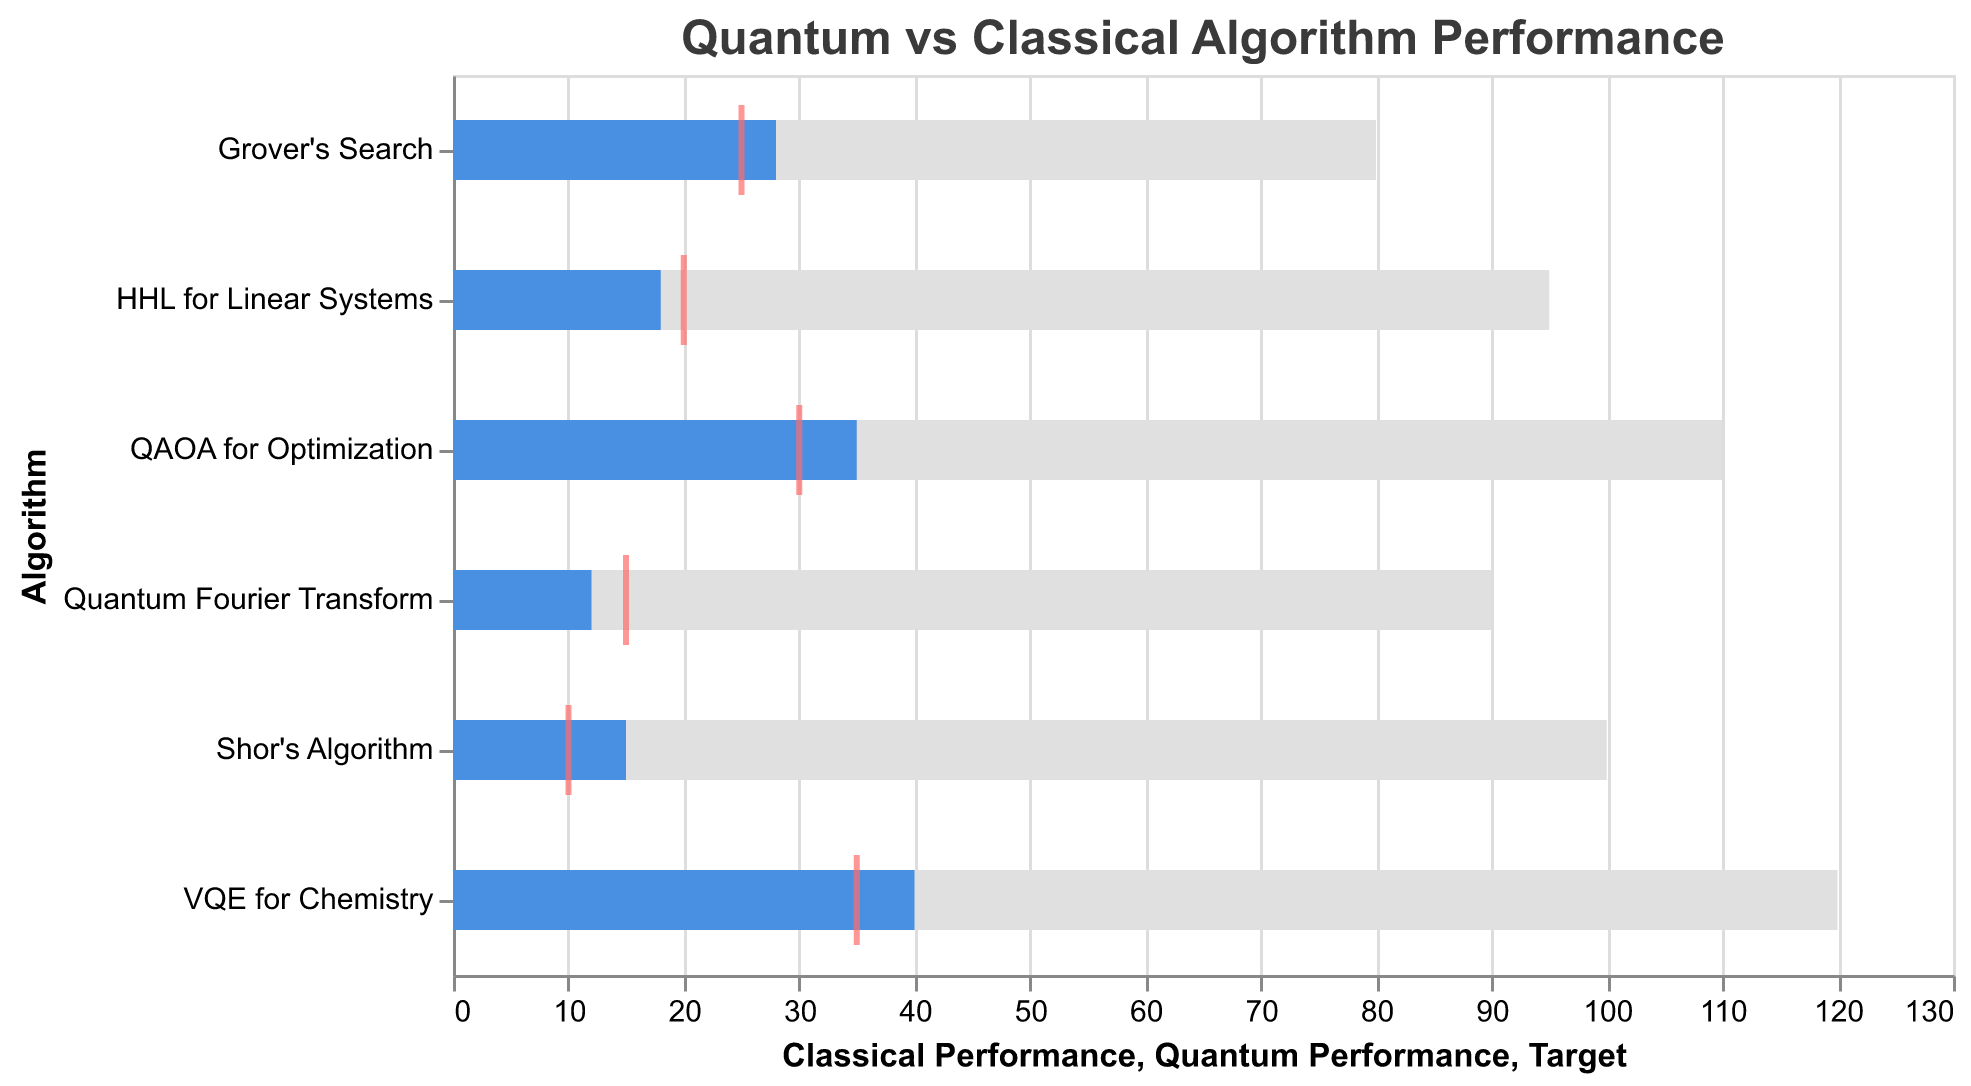What's the title of the figure? The title of the figure is written at the top and usually describes the main subject of the plot. Here, it reads "Quantum vs Classical Algorithm Performance".
Answer: Quantum vs Classical Algorithm Performance What does the gray bar represent? The gray bar represents the Classical Performance for each algorithm. This can be inferred from the visual contrast and the domain values on the x-axis.
Answer: Classical Performance Which algorithm has the highest Classical Performance? To find the highest Classical Performance, look at the longest gray bar on the x-axis. The longest gray bar corresponds to "VQE for Chemistry" with a value of 120.
Answer: VQE for Chemistry What's the Quantum Performance for Grover's Search? The Quantum Performance for Grover's Search is represented by the blue bar. By looking at the length of the blue bar, we can see that its value is 28.
Answer: 28 Which algorithms have a Quantum Performance lower than their Target? To determine which algorithms meet this condition, compare the length of the blue bars (Quantum Performance) with the position of the red ticks (Target). The algorithms are "Shor's Algorithm", "Quantum Fourier Transform", and "HHL for Linear Systems".
Answer: Shor's Algorithm, Quantum Fourier Transform, HHL for Linear Systems What's the difference between Classical and Quantum Performance for QAOA for Optimization? Calculate the difference by subtracting the Quantum Performance (35) from the Classical Performance (110), which is 110 - 35 = 75.
Answer: 75 Which algorithm is closest to meeting its Target in Quantum Performance? To find this, calculate the absolute difference between the Quantum Performance (blue bar) and the Target (red tick) for each algorithm. The smallest difference for "Grover's Search" is 3 (28 - 25).
Answer: Grover's Search What's the average Target value across all algorithms? Sum up all the Target values (10 + 25 + 15 + 35 + 30 + 20 = 135) and divide by the number of algorithms (6). So, the average is 135 / 6 = 22.5.
Answer: 22.5 Which algorithm shows the greatest improvement by moving from Classical to Quantum Performance? To find the greatest improvement, calculate the performance reduction (Classical - Quantum) for each algorithm. The largest reduction is for "Shor's Algorithm" with 100 - 15 = 85.
Answer: Shor's Algorithm Is there any algorithm where the Quantum Performance is equivalent to the Target? By examining the position of the blue bars and the red ticks, it is clear that none of the Quantum Performances exactly match the Targets.
Answer: No 